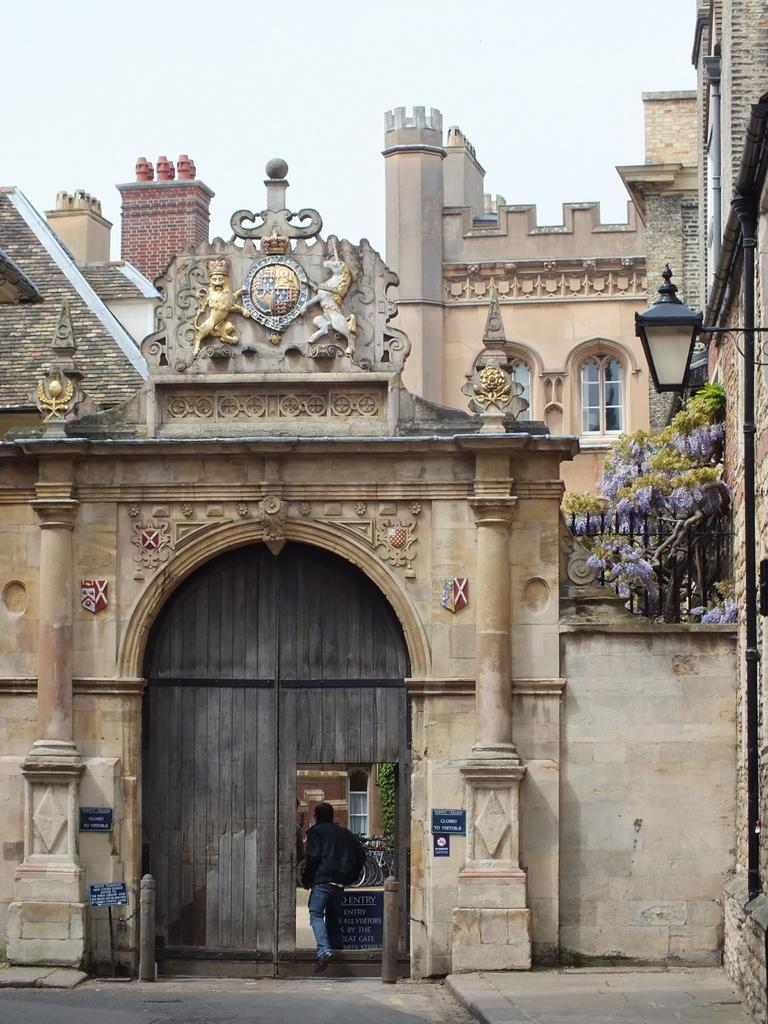What is the main structure in the image? There is a building in the image. Is there anyone present in the image? Yes, there is a person in the image. What is the person wearing? The person is wearing a bag. What is the person doing in the image? The person is entering the building. How many heads of lettuce can be seen on the person's shoulders in the image? There are no heads of lettuce present in the image; the person is wearing a bag. 